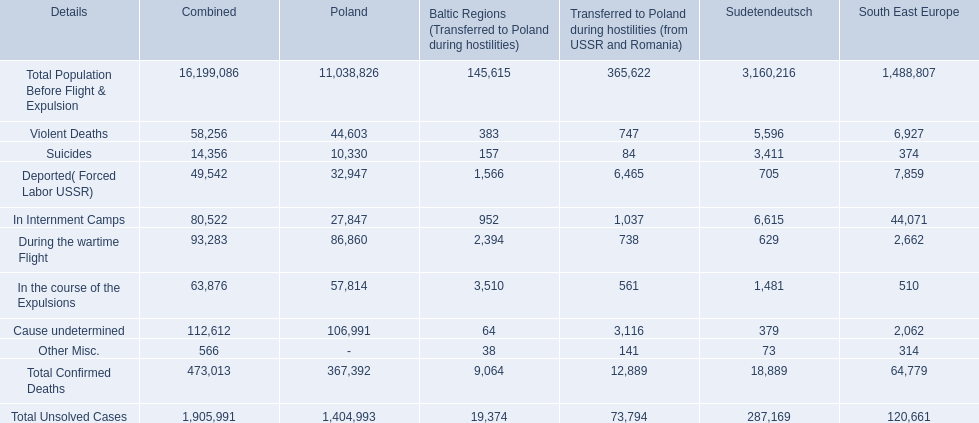What are the numbers of violent deaths across the area? 44,603, 383, 747, 5,596, 6,927. What is the total number of violent deaths of the area? 58,256. 